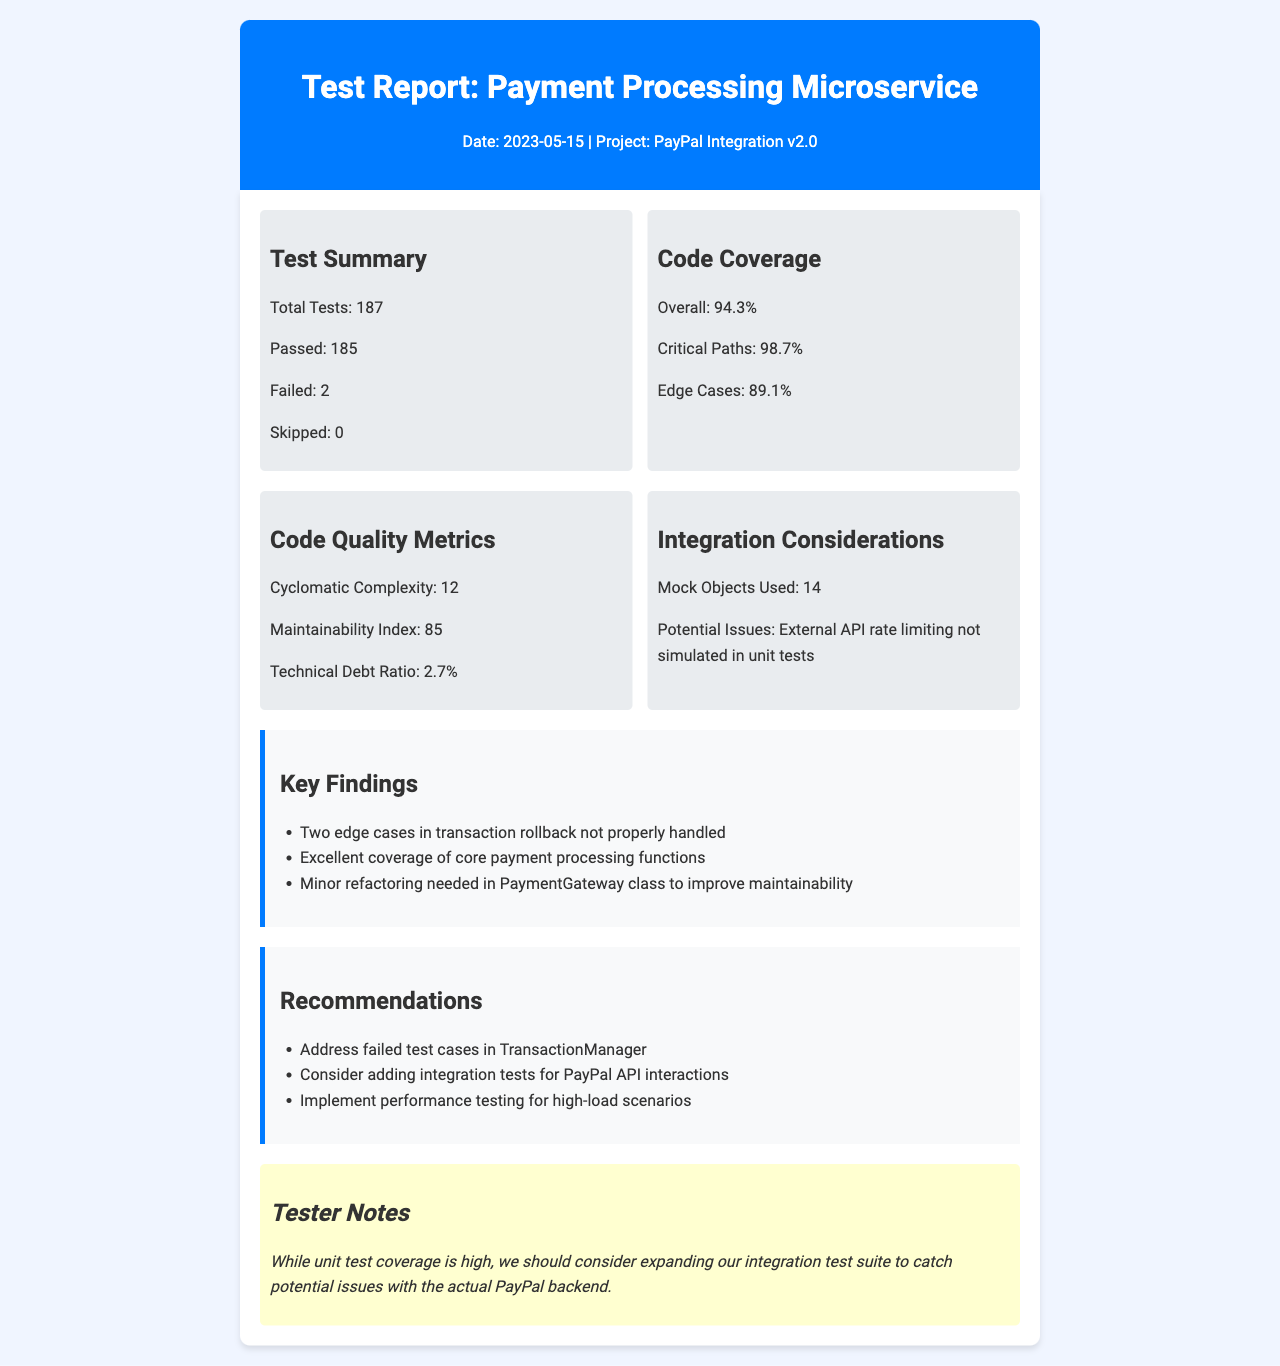What is the date of the test report? The date is stated in the fax header at the top of the document.
Answer: 2023-05-15 What is the total number of tests conducted? The total tests are listed in the Test Summary section of the document.
Answer: 187 How many tests passed? The number of passed tests is mentioned in the same section as the total tests.
Answer: 185 What is the overall code coverage percentage? The overall code coverage is indicated in the Code Coverage section of the document.
Answer: 94.3% What is the maintainability index? This metric is found in the Code Quality Metrics section of the report.
Answer: 85 What was the technical debt ratio? The technical debt ratio is located within the same section as the maintainability index.
Answer: 2.7% What are the potential issues noted in the report? Potential issues can be found in the Integration Considerations section.
Answer: External API rate limiting not simulated in unit tests What should be addressed according to the recommendations? Recommendations for action can be found in the Recommendations section.
Answer: Failed test cases in TransactionManager What is one key finding from the report? Key findings are summarized in the Key Findings section, which lists several observations.
Answer: Two edge cases in transaction rollback not properly handled 